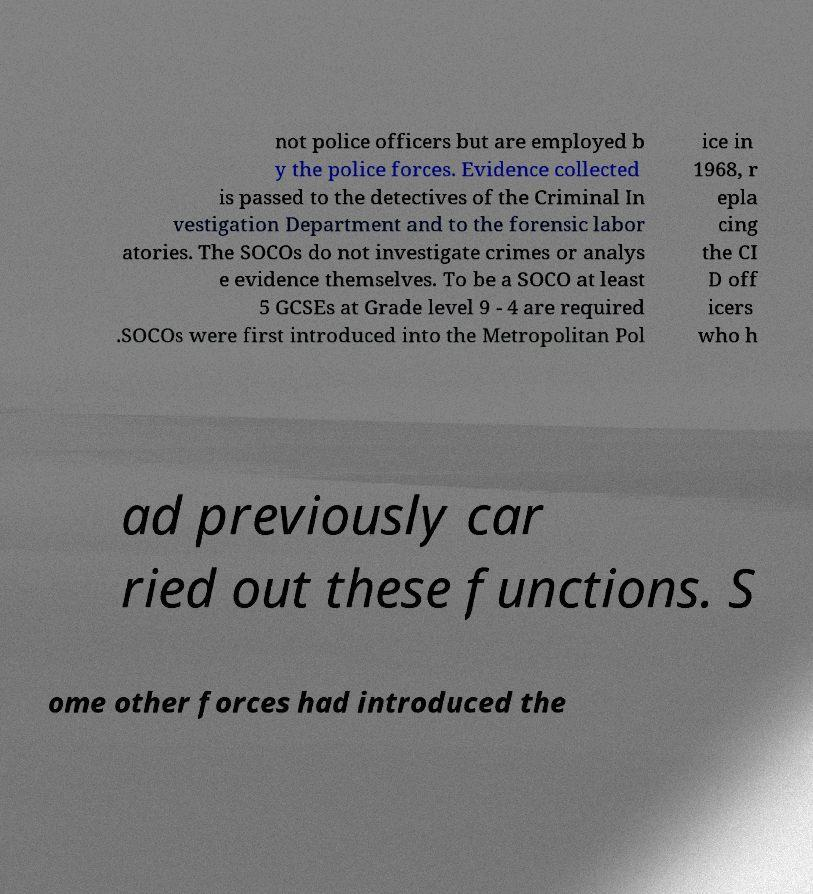Could you extract and type out the text from this image? not police officers but are employed b y the police forces. Evidence collected is passed to the detectives of the Criminal In vestigation Department and to the forensic labor atories. The SOCOs do not investigate crimes or analys e evidence themselves. To be a SOCO at least 5 GCSEs at Grade level 9 - 4 are required .SOCOs were first introduced into the Metropolitan Pol ice in 1968, r epla cing the CI D off icers who h ad previously car ried out these functions. S ome other forces had introduced the 